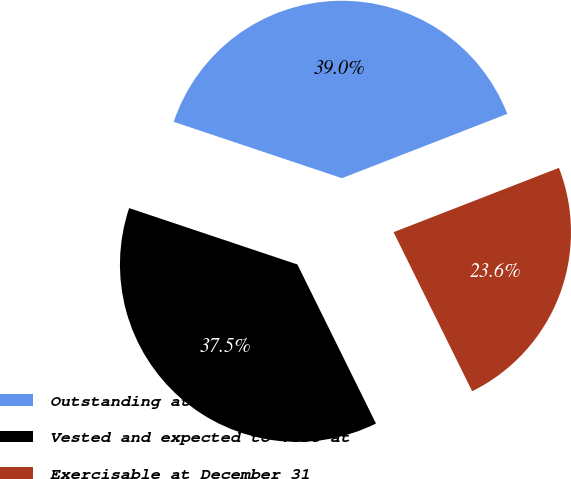Convert chart. <chart><loc_0><loc_0><loc_500><loc_500><pie_chart><fcel>Outstanding at December 31<fcel>Vested and expected to vest at<fcel>Exercisable at December 31<nl><fcel>38.95%<fcel>37.45%<fcel>23.6%<nl></chart> 